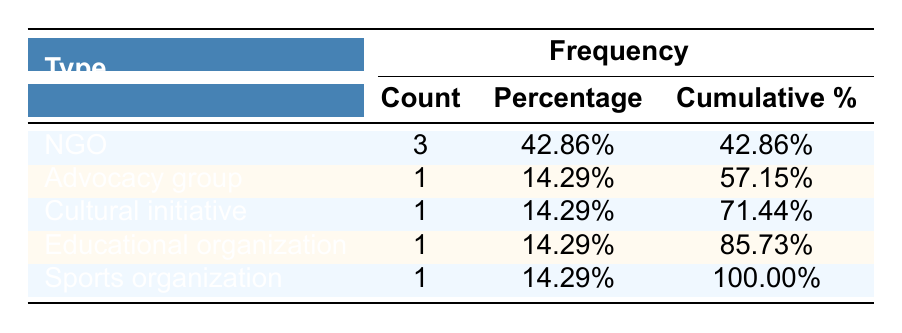What is the total count of supportive organizations listed in the table? By looking at the 'Count' column, we can see the numbers for each organization type: NGO (3), Advocacy group (1), Cultural initiative (1), Educational organization (1), and Sports organization (1). Adding these counts gives us 3 + 1 + 1 + 1 + 1 = 7.
Answer: 7 What percentage of the supportive organizations are NGOs? The count of NGOs is 3, and the total count of organizations is 7. To find the percentage, we use the formula: (3/7) * 100 = 42.86%.
Answer: 42.86% How many organization types focus on educational support? From the table, only one organization type—Educational organization—focuses on legal education and outreach.
Answer: 1 Is there an advocacy group listed in the supportive organizations? Yes, according to the table, there is 1 organization that fits into the 'Advocacy group' category.
Answer: Yes What percentage of organizations focus on non-NGO types? The non-NGO types include Advocacy group, Cultural initiative, Educational organization, and Sports organization, which total to 4 organizations. Thus, the percentage is (4/7) * 100 = 57.14%.
Answer: 57.14% Which type of organization has the least representation in the table? Examining the 'Count' column, we see that the categories Advocacy group, Cultural initiative, Educational organization, and Sports organization each have 1 count, which is the least representation.
Answer: Advocacy group, Cultural initiative, Educational organization, Sports organization What is the cumulative percentage for NGOs and Advocacy groups combined? The cumulative percentage for NGOs is 42.86% and for Advocacy group is an additional 14.29%. Adding these gives 42.86 + 14.29 = 57.15%.
Answer: 57.15% How many more NGOs are there compared to Sports organizations? There are 3 NGOs and 1 Sports organization. Therefore, the difference is 3 - 1 = 2 more NGOs than Sports organizations.
Answer: 2 If we were to categorize the organizations by their focus areas, which area has the highest frequency? The focus areas in the table show that NGOs outnumber all other types (3 NGOs), making 'Legal support, social services' the focus area associated with the highest frequency overall.
Answer: Legal support, social services What is the ratio of cultural initiatives to total organizations? There is 1 cultural initiative and a total of 7 organizations. Therefore, the ratio is 1:7.
Answer: 1:7 